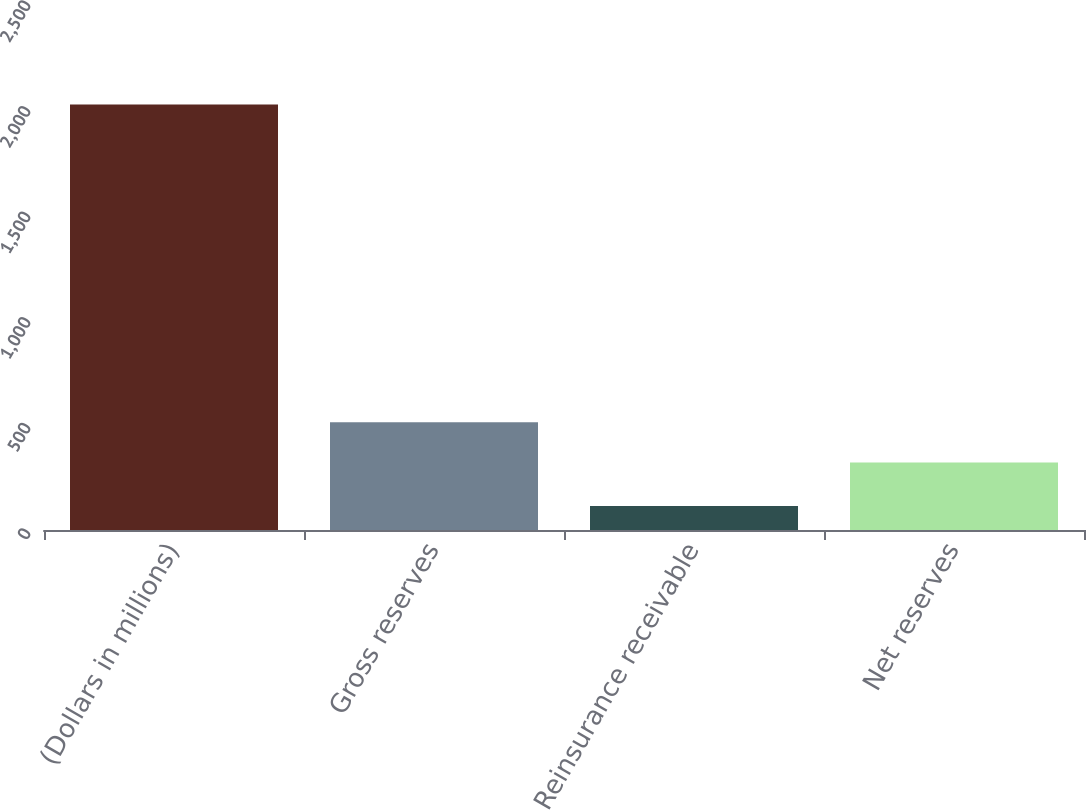Convert chart to OTSL. <chart><loc_0><loc_0><loc_500><loc_500><bar_chart><fcel>(Dollars in millions)<fcel>Gross reserves<fcel>Reinsurance receivable<fcel>Net reserves<nl><fcel>2015<fcel>509.75<fcel>113.5<fcel>319.6<nl></chart> 